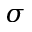<formula> <loc_0><loc_0><loc_500><loc_500>\sigma</formula> 